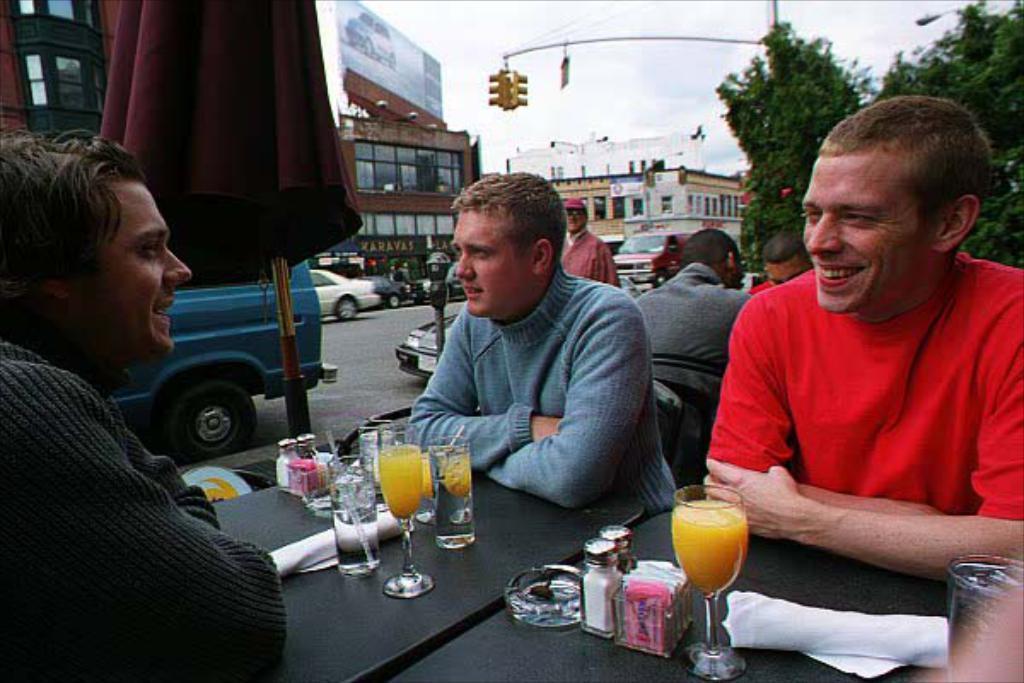Describe this image in one or two sentences. In this picture there are three men sitting and talking they have a table in front of them with some juice, sprinklers, tissues, water glass, paper and in the background there are buildings, trees, traffic light, vehicles passing on and the sky is clear 